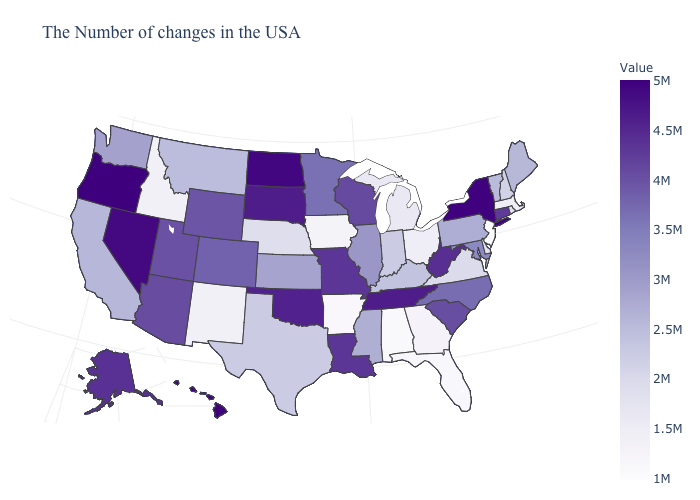Which states hav the highest value in the West?
Answer briefly. Oregon. Does Delaware have the highest value in the USA?
Concise answer only. No. Does New Jersey have the lowest value in the USA?
Quick response, please. Yes. Does South Carolina have a lower value than Nevada?
Be succinct. Yes. Does North Carolina have a higher value than Michigan?
Give a very brief answer. Yes. 